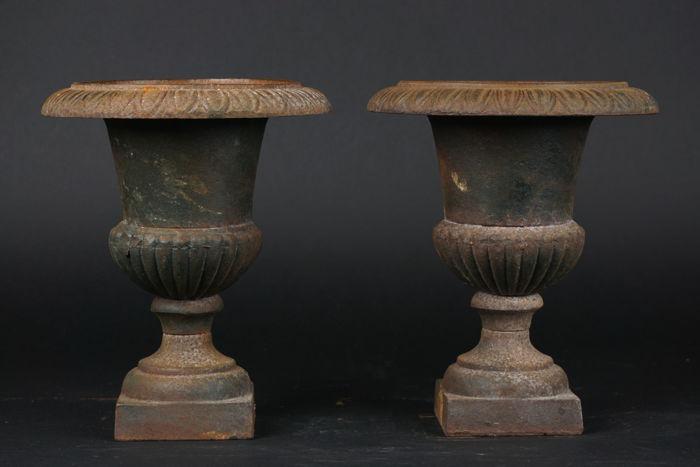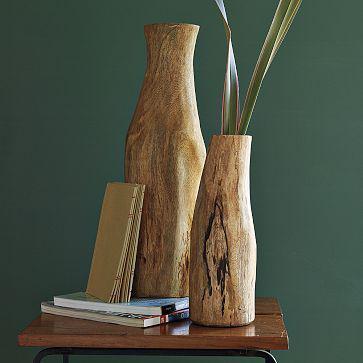The first image is the image on the left, the second image is the image on the right. Considering the images on both sides, is "Floral arrangements are in all vases." valid? Answer yes or no. No. 